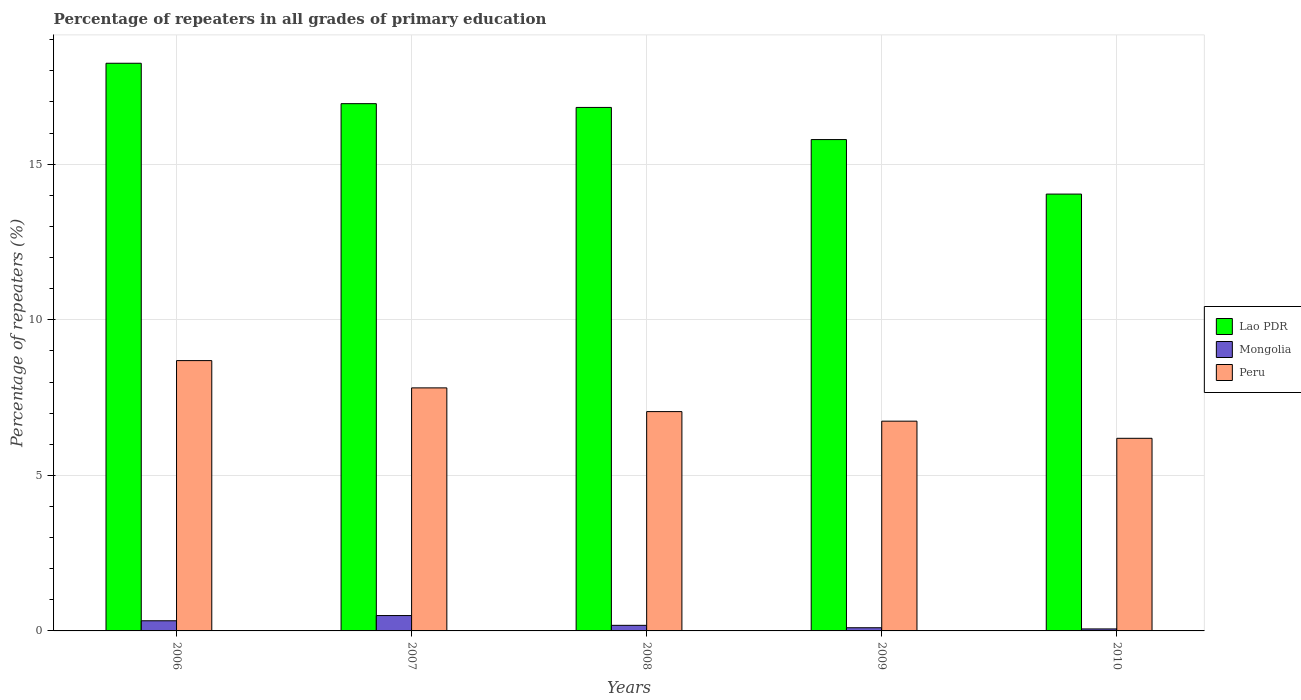Are the number of bars on each tick of the X-axis equal?
Offer a very short reply. Yes. What is the label of the 1st group of bars from the left?
Make the answer very short. 2006. In how many cases, is the number of bars for a given year not equal to the number of legend labels?
Provide a succinct answer. 0. What is the percentage of repeaters in Mongolia in 2007?
Make the answer very short. 0.49. Across all years, what is the maximum percentage of repeaters in Lao PDR?
Ensure brevity in your answer.  18.24. Across all years, what is the minimum percentage of repeaters in Lao PDR?
Give a very brief answer. 14.04. In which year was the percentage of repeaters in Lao PDR maximum?
Make the answer very short. 2006. What is the total percentage of repeaters in Mongolia in the graph?
Your answer should be very brief. 1.17. What is the difference between the percentage of repeaters in Peru in 2006 and that in 2009?
Provide a succinct answer. 1.95. What is the difference between the percentage of repeaters in Peru in 2008 and the percentage of repeaters in Mongolia in 2009?
Keep it short and to the point. 6.95. What is the average percentage of repeaters in Peru per year?
Keep it short and to the point. 7.3. In the year 2007, what is the difference between the percentage of repeaters in Peru and percentage of repeaters in Lao PDR?
Your answer should be compact. -9.13. In how many years, is the percentage of repeaters in Mongolia greater than 2 %?
Keep it short and to the point. 0. What is the ratio of the percentage of repeaters in Mongolia in 2006 to that in 2009?
Provide a succinct answer. 3.19. Is the difference between the percentage of repeaters in Peru in 2008 and 2009 greater than the difference between the percentage of repeaters in Lao PDR in 2008 and 2009?
Ensure brevity in your answer.  No. What is the difference between the highest and the second highest percentage of repeaters in Peru?
Your response must be concise. 0.88. What is the difference between the highest and the lowest percentage of repeaters in Peru?
Give a very brief answer. 2.5. Is the sum of the percentage of repeaters in Mongolia in 2008 and 2010 greater than the maximum percentage of repeaters in Lao PDR across all years?
Make the answer very short. No. What does the 1st bar from the left in 2006 represents?
Offer a terse response. Lao PDR. What does the 2nd bar from the right in 2009 represents?
Give a very brief answer. Mongolia. Is it the case that in every year, the sum of the percentage of repeaters in Peru and percentage of repeaters in Lao PDR is greater than the percentage of repeaters in Mongolia?
Your answer should be compact. Yes. How many years are there in the graph?
Your answer should be very brief. 5. Does the graph contain any zero values?
Your response must be concise. No. Does the graph contain grids?
Your response must be concise. Yes. What is the title of the graph?
Your answer should be compact. Percentage of repeaters in all grades of primary education. What is the label or title of the X-axis?
Offer a terse response. Years. What is the label or title of the Y-axis?
Keep it short and to the point. Percentage of repeaters (%). What is the Percentage of repeaters (%) in Lao PDR in 2006?
Provide a short and direct response. 18.24. What is the Percentage of repeaters (%) in Mongolia in 2006?
Keep it short and to the point. 0.33. What is the Percentage of repeaters (%) in Peru in 2006?
Your response must be concise. 8.69. What is the Percentage of repeaters (%) in Lao PDR in 2007?
Make the answer very short. 16.95. What is the Percentage of repeaters (%) in Mongolia in 2007?
Your answer should be compact. 0.49. What is the Percentage of repeaters (%) in Peru in 2007?
Give a very brief answer. 7.81. What is the Percentage of repeaters (%) of Lao PDR in 2008?
Offer a very short reply. 16.82. What is the Percentage of repeaters (%) in Mongolia in 2008?
Your answer should be compact. 0.18. What is the Percentage of repeaters (%) in Peru in 2008?
Your answer should be very brief. 7.05. What is the Percentage of repeaters (%) in Lao PDR in 2009?
Ensure brevity in your answer.  15.79. What is the Percentage of repeaters (%) in Mongolia in 2009?
Your answer should be compact. 0.1. What is the Percentage of repeaters (%) of Peru in 2009?
Offer a terse response. 6.74. What is the Percentage of repeaters (%) in Lao PDR in 2010?
Offer a terse response. 14.04. What is the Percentage of repeaters (%) of Mongolia in 2010?
Keep it short and to the point. 0.06. What is the Percentage of repeaters (%) of Peru in 2010?
Your answer should be compact. 6.19. Across all years, what is the maximum Percentage of repeaters (%) of Lao PDR?
Provide a succinct answer. 18.24. Across all years, what is the maximum Percentage of repeaters (%) in Mongolia?
Make the answer very short. 0.49. Across all years, what is the maximum Percentage of repeaters (%) in Peru?
Offer a terse response. 8.69. Across all years, what is the minimum Percentage of repeaters (%) of Lao PDR?
Your answer should be very brief. 14.04. Across all years, what is the minimum Percentage of repeaters (%) in Mongolia?
Provide a succinct answer. 0.06. Across all years, what is the minimum Percentage of repeaters (%) in Peru?
Provide a succinct answer. 6.19. What is the total Percentage of repeaters (%) in Lao PDR in the graph?
Offer a very short reply. 81.85. What is the total Percentage of repeaters (%) in Mongolia in the graph?
Provide a succinct answer. 1.17. What is the total Percentage of repeaters (%) of Peru in the graph?
Keep it short and to the point. 36.48. What is the difference between the Percentage of repeaters (%) in Lao PDR in 2006 and that in 2007?
Offer a very short reply. 1.3. What is the difference between the Percentage of repeaters (%) in Mongolia in 2006 and that in 2007?
Provide a short and direct response. -0.17. What is the difference between the Percentage of repeaters (%) in Peru in 2006 and that in 2007?
Your answer should be compact. 0.88. What is the difference between the Percentage of repeaters (%) of Lao PDR in 2006 and that in 2008?
Make the answer very short. 1.42. What is the difference between the Percentage of repeaters (%) in Mongolia in 2006 and that in 2008?
Provide a short and direct response. 0.15. What is the difference between the Percentage of repeaters (%) in Peru in 2006 and that in 2008?
Keep it short and to the point. 1.64. What is the difference between the Percentage of repeaters (%) in Lao PDR in 2006 and that in 2009?
Provide a short and direct response. 2.45. What is the difference between the Percentage of repeaters (%) of Mongolia in 2006 and that in 2009?
Provide a succinct answer. 0.22. What is the difference between the Percentage of repeaters (%) of Peru in 2006 and that in 2009?
Offer a terse response. 1.95. What is the difference between the Percentage of repeaters (%) in Lao PDR in 2006 and that in 2010?
Provide a succinct answer. 4.2. What is the difference between the Percentage of repeaters (%) in Mongolia in 2006 and that in 2010?
Ensure brevity in your answer.  0.26. What is the difference between the Percentage of repeaters (%) in Peru in 2006 and that in 2010?
Provide a short and direct response. 2.5. What is the difference between the Percentage of repeaters (%) of Lao PDR in 2007 and that in 2008?
Offer a very short reply. 0.12. What is the difference between the Percentage of repeaters (%) of Mongolia in 2007 and that in 2008?
Ensure brevity in your answer.  0.31. What is the difference between the Percentage of repeaters (%) of Peru in 2007 and that in 2008?
Give a very brief answer. 0.76. What is the difference between the Percentage of repeaters (%) in Lao PDR in 2007 and that in 2009?
Provide a short and direct response. 1.15. What is the difference between the Percentage of repeaters (%) of Mongolia in 2007 and that in 2009?
Your answer should be compact. 0.39. What is the difference between the Percentage of repeaters (%) in Peru in 2007 and that in 2009?
Make the answer very short. 1.07. What is the difference between the Percentage of repeaters (%) of Lao PDR in 2007 and that in 2010?
Your response must be concise. 2.91. What is the difference between the Percentage of repeaters (%) in Mongolia in 2007 and that in 2010?
Keep it short and to the point. 0.43. What is the difference between the Percentage of repeaters (%) in Peru in 2007 and that in 2010?
Offer a very short reply. 1.62. What is the difference between the Percentage of repeaters (%) of Lao PDR in 2008 and that in 2009?
Offer a very short reply. 1.03. What is the difference between the Percentage of repeaters (%) in Mongolia in 2008 and that in 2009?
Your response must be concise. 0.08. What is the difference between the Percentage of repeaters (%) of Peru in 2008 and that in 2009?
Provide a succinct answer. 0.31. What is the difference between the Percentage of repeaters (%) of Lao PDR in 2008 and that in 2010?
Offer a very short reply. 2.79. What is the difference between the Percentage of repeaters (%) in Mongolia in 2008 and that in 2010?
Your response must be concise. 0.12. What is the difference between the Percentage of repeaters (%) of Peru in 2008 and that in 2010?
Offer a terse response. 0.86. What is the difference between the Percentage of repeaters (%) of Lao PDR in 2009 and that in 2010?
Your response must be concise. 1.75. What is the difference between the Percentage of repeaters (%) in Mongolia in 2009 and that in 2010?
Provide a short and direct response. 0.04. What is the difference between the Percentage of repeaters (%) in Peru in 2009 and that in 2010?
Ensure brevity in your answer.  0.55. What is the difference between the Percentage of repeaters (%) of Lao PDR in 2006 and the Percentage of repeaters (%) of Mongolia in 2007?
Offer a terse response. 17.75. What is the difference between the Percentage of repeaters (%) of Lao PDR in 2006 and the Percentage of repeaters (%) of Peru in 2007?
Provide a short and direct response. 10.43. What is the difference between the Percentage of repeaters (%) of Mongolia in 2006 and the Percentage of repeaters (%) of Peru in 2007?
Keep it short and to the point. -7.49. What is the difference between the Percentage of repeaters (%) of Lao PDR in 2006 and the Percentage of repeaters (%) of Mongolia in 2008?
Provide a succinct answer. 18.07. What is the difference between the Percentage of repeaters (%) of Lao PDR in 2006 and the Percentage of repeaters (%) of Peru in 2008?
Provide a short and direct response. 11.2. What is the difference between the Percentage of repeaters (%) of Mongolia in 2006 and the Percentage of repeaters (%) of Peru in 2008?
Offer a terse response. -6.72. What is the difference between the Percentage of repeaters (%) in Lao PDR in 2006 and the Percentage of repeaters (%) in Mongolia in 2009?
Ensure brevity in your answer.  18.14. What is the difference between the Percentage of repeaters (%) in Lao PDR in 2006 and the Percentage of repeaters (%) in Peru in 2009?
Provide a short and direct response. 11.5. What is the difference between the Percentage of repeaters (%) in Mongolia in 2006 and the Percentage of repeaters (%) in Peru in 2009?
Your answer should be compact. -6.42. What is the difference between the Percentage of repeaters (%) of Lao PDR in 2006 and the Percentage of repeaters (%) of Mongolia in 2010?
Offer a terse response. 18.18. What is the difference between the Percentage of repeaters (%) in Lao PDR in 2006 and the Percentage of repeaters (%) in Peru in 2010?
Your response must be concise. 12.05. What is the difference between the Percentage of repeaters (%) in Mongolia in 2006 and the Percentage of repeaters (%) in Peru in 2010?
Offer a terse response. -5.86. What is the difference between the Percentage of repeaters (%) in Lao PDR in 2007 and the Percentage of repeaters (%) in Mongolia in 2008?
Provide a succinct answer. 16.77. What is the difference between the Percentage of repeaters (%) in Lao PDR in 2007 and the Percentage of repeaters (%) in Peru in 2008?
Keep it short and to the point. 9.9. What is the difference between the Percentage of repeaters (%) in Mongolia in 2007 and the Percentage of repeaters (%) in Peru in 2008?
Make the answer very short. -6.55. What is the difference between the Percentage of repeaters (%) in Lao PDR in 2007 and the Percentage of repeaters (%) in Mongolia in 2009?
Ensure brevity in your answer.  16.84. What is the difference between the Percentage of repeaters (%) of Lao PDR in 2007 and the Percentage of repeaters (%) of Peru in 2009?
Make the answer very short. 10.2. What is the difference between the Percentage of repeaters (%) of Mongolia in 2007 and the Percentage of repeaters (%) of Peru in 2009?
Make the answer very short. -6.25. What is the difference between the Percentage of repeaters (%) in Lao PDR in 2007 and the Percentage of repeaters (%) in Mongolia in 2010?
Provide a short and direct response. 16.88. What is the difference between the Percentage of repeaters (%) in Lao PDR in 2007 and the Percentage of repeaters (%) in Peru in 2010?
Keep it short and to the point. 10.76. What is the difference between the Percentage of repeaters (%) of Mongolia in 2007 and the Percentage of repeaters (%) of Peru in 2010?
Provide a short and direct response. -5.7. What is the difference between the Percentage of repeaters (%) of Lao PDR in 2008 and the Percentage of repeaters (%) of Mongolia in 2009?
Give a very brief answer. 16.72. What is the difference between the Percentage of repeaters (%) in Lao PDR in 2008 and the Percentage of repeaters (%) in Peru in 2009?
Offer a terse response. 10.08. What is the difference between the Percentage of repeaters (%) in Mongolia in 2008 and the Percentage of repeaters (%) in Peru in 2009?
Ensure brevity in your answer.  -6.56. What is the difference between the Percentage of repeaters (%) of Lao PDR in 2008 and the Percentage of repeaters (%) of Mongolia in 2010?
Provide a short and direct response. 16.76. What is the difference between the Percentage of repeaters (%) in Lao PDR in 2008 and the Percentage of repeaters (%) in Peru in 2010?
Provide a short and direct response. 10.63. What is the difference between the Percentage of repeaters (%) in Mongolia in 2008 and the Percentage of repeaters (%) in Peru in 2010?
Offer a very short reply. -6.01. What is the difference between the Percentage of repeaters (%) in Lao PDR in 2009 and the Percentage of repeaters (%) in Mongolia in 2010?
Provide a succinct answer. 15.73. What is the difference between the Percentage of repeaters (%) in Lao PDR in 2009 and the Percentage of repeaters (%) in Peru in 2010?
Your response must be concise. 9.6. What is the difference between the Percentage of repeaters (%) of Mongolia in 2009 and the Percentage of repeaters (%) of Peru in 2010?
Offer a very short reply. -6.09. What is the average Percentage of repeaters (%) of Lao PDR per year?
Your answer should be very brief. 16.37. What is the average Percentage of repeaters (%) of Mongolia per year?
Keep it short and to the point. 0.23. What is the average Percentage of repeaters (%) of Peru per year?
Your response must be concise. 7.3. In the year 2006, what is the difference between the Percentage of repeaters (%) in Lao PDR and Percentage of repeaters (%) in Mongolia?
Provide a succinct answer. 17.92. In the year 2006, what is the difference between the Percentage of repeaters (%) of Lao PDR and Percentage of repeaters (%) of Peru?
Offer a terse response. 9.56. In the year 2006, what is the difference between the Percentage of repeaters (%) in Mongolia and Percentage of repeaters (%) in Peru?
Your answer should be compact. -8.36. In the year 2007, what is the difference between the Percentage of repeaters (%) of Lao PDR and Percentage of repeaters (%) of Mongolia?
Keep it short and to the point. 16.45. In the year 2007, what is the difference between the Percentage of repeaters (%) in Lao PDR and Percentage of repeaters (%) in Peru?
Make the answer very short. 9.13. In the year 2007, what is the difference between the Percentage of repeaters (%) in Mongolia and Percentage of repeaters (%) in Peru?
Offer a very short reply. -7.32. In the year 2008, what is the difference between the Percentage of repeaters (%) in Lao PDR and Percentage of repeaters (%) in Mongolia?
Keep it short and to the point. 16.65. In the year 2008, what is the difference between the Percentage of repeaters (%) in Lao PDR and Percentage of repeaters (%) in Peru?
Your answer should be compact. 9.78. In the year 2008, what is the difference between the Percentage of repeaters (%) in Mongolia and Percentage of repeaters (%) in Peru?
Keep it short and to the point. -6.87. In the year 2009, what is the difference between the Percentage of repeaters (%) in Lao PDR and Percentage of repeaters (%) in Mongolia?
Keep it short and to the point. 15.69. In the year 2009, what is the difference between the Percentage of repeaters (%) in Lao PDR and Percentage of repeaters (%) in Peru?
Give a very brief answer. 9.05. In the year 2009, what is the difference between the Percentage of repeaters (%) in Mongolia and Percentage of repeaters (%) in Peru?
Ensure brevity in your answer.  -6.64. In the year 2010, what is the difference between the Percentage of repeaters (%) in Lao PDR and Percentage of repeaters (%) in Mongolia?
Offer a very short reply. 13.98. In the year 2010, what is the difference between the Percentage of repeaters (%) of Lao PDR and Percentage of repeaters (%) of Peru?
Make the answer very short. 7.85. In the year 2010, what is the difference between the Percentage of repeaters (%) of Mongolia and Percentage of repeaters (%) of Peru?
Keep it short and to the point. -6.13. What is the ratio of the Percentage of repeaters (%) in Lao PDR in 2006 to that in 2007?
Offer a very short reply. 1.08. What is the ratio of the Percentage of repeaters (%) in Mongolia in 2006 to that in 2007?
Your answer should be very brief. 0.66. What is the ratio of the Percentage of repeaters (%) of Peru in 2006 to that in 2007?
Provide a succinct answer. 1.11. What is the ratio of the Percentage of repeaters (%) in Lao PDR in 2006 to that in 2008?
Provide a succinct answer. 1.08. What is the ratio of the Percentage of repeaters (%) of Mongolia in 2006 to that in 2008?
Provide a short and direct response. 1.82. What is the ratio of the Percentage of repeaters (%) of Peru in 2006 to that in 2008?
Provide a succinct answer. 1.23. What is the ratio of the Percentage of repeaters (%) in Lao PDR in 2006 to that in 2009?
Make the answer very short. 1.16. What is the ratio of the Percentage of repeaters (%) of Mongolia in 2006 to that in 2009?
Your answer should be compact. 3.19. What is the ratio of the Percentage of repeaters (%) of Peru in 2006 to that in 2009?
Provide a succinct answer. 1.29. What is the ratio of the Percentage of repeaters (%) of Lao PDR in 2006 to that in 2010?
Your answer should be very brief. 1.3. What is the ratio of the Percentage of repeaters (%) in Mongolia in 2006 to that in 2010?
Your answer should be compact. 5.08. What is the ratio of the Percentage of repeaters (%) in Peru in 2006 to that in 2010?
Ensure brevity in your answer.  1.4. What is the ratio of the Percentage of repeaters (%) in Mongolia in 2007 to that in 2008?
Offer a terse response. 2.75. What is the ratio of the Percentage of repeaters (%) of Peru in 2007 to that in 2008?
Offer a terse response. 1.11. What is the ratio of the Percentage of repeaters (%) of Lao PDR in 2007 to that in 2009?
Keep it short and to the point. 1.07. What is the ratio of the Percentage of repeaters (%) in Mongolia in 2007 to that in 2009?
Provide a short and direct response. 4.84. What is the ratio of the Percentage of repeaters (%) of Peru in 2007 to that in 2009?
Your answer should be very brief. 1.16. What is the ratio of the Percentage of repeaters (%) of Lao PDR in 2007 to that in 2010?
Offer a terse response. 1.21. What is the ratio of the Percentage of repeaters (%) of Mongolia in 2007 to that in 2010?
Offer a terse response. 7.69. What is the ratio of the Percentage of repeaters (%) of Peru in 2007 to that in 2010?
Ensure brevity in your answer.  1.26. What is the ratio of the Percentage of repeaters (%) in Lao PDR in 2008 to that in 2009?
Your answer should be compact. 1.07. What is the ratio of the Percentage of repeaters (%) of Mongolia in 2008 to that in 2009?
Give a very brief answer. 1.76. What is the ratio of the Percentage of repeaters (%) of Peru in 2008 to that in 2009?
Give a very brief answer. 1.05. What is the ratio of the Percentage of repeaters (%) of Lao PDR in 2008 to that in 2010?
Your answer should be very brief. 1.2. What is the ratio of the Percentage of repeaters (%) in Mongolia in 2008 to that in 2010?
Provide a short and direct response. 2.79. What is the ratio of the Percentage of repeaters (%) of Peru in 2008 to that in 2010?
Offer a terse response. 1.14. What is the ratio of the Percentage of repeaters (%) in Lao PDR in 2009 to that in 2010?
Offer a terse response. 1.12. What is the ratio of the Percentage of repeaters (%) of Mongolia in 2009 to that in 2010?
Provide a succinct answer. 1.59. What is the ratio of the Percentage of repeaters (%) of Peru in 2009 to that in 2010?
Make the answer very short. 1.09. What is the difference between the highest and the second highest Percentage of repeaters (%) of Lao PDR?
Your answer should be very brief. 1.3. What is the difference between the highest and the second highest Percentage of repeaters (%) in Mongolia?
Keep it short and to the point. 0.17. What is the difference between the highest and the second highest Percentage of repeaters (%) of Peru?
Your answer should be very brief. 0.88. What is the difference between the highest and the lowest Percentage of repeaters (%) in Lao PDR?
Your answer should be compact. 4.2. What is the difference between the highest and the lowest Percentage of repeaters (%) of Mongolia?
Your answer should be very brief. 0.43. What is the difference between the highest and the lowest Percentage of repeaters (%) of Peru?
Provide a succinct answer. 2.5. 